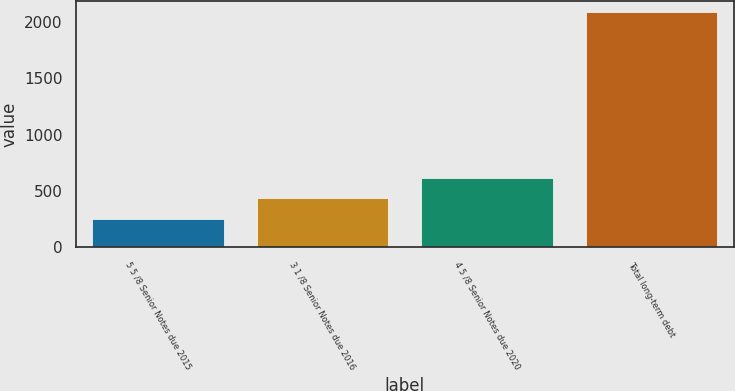Convert chart to OTSL. <chart><loc_0><loc_0><loc_500><loc_500><bar_chart><fcel>5 5 /8 Senior Notes due 2015<fcel>3 1 /8 Senior Notes due 2016<fcel>4 5 /8 Senior Notes due 2020<fcel>Total long-term debt<nl><fcel>250<fcel>433.55<fcel>617.1<fcel>2085.5<nl></chart> 